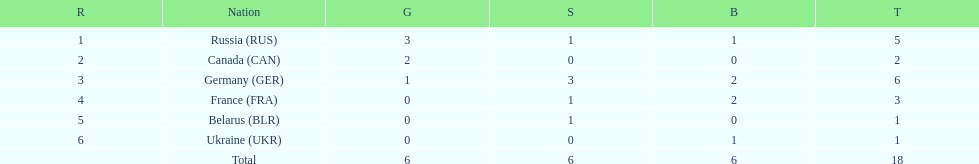What were the only 3 countries to win gold medals at the the 1994 winter olympics biathlon? Russia (RUS), Canada (CAN), Germany (GER). 